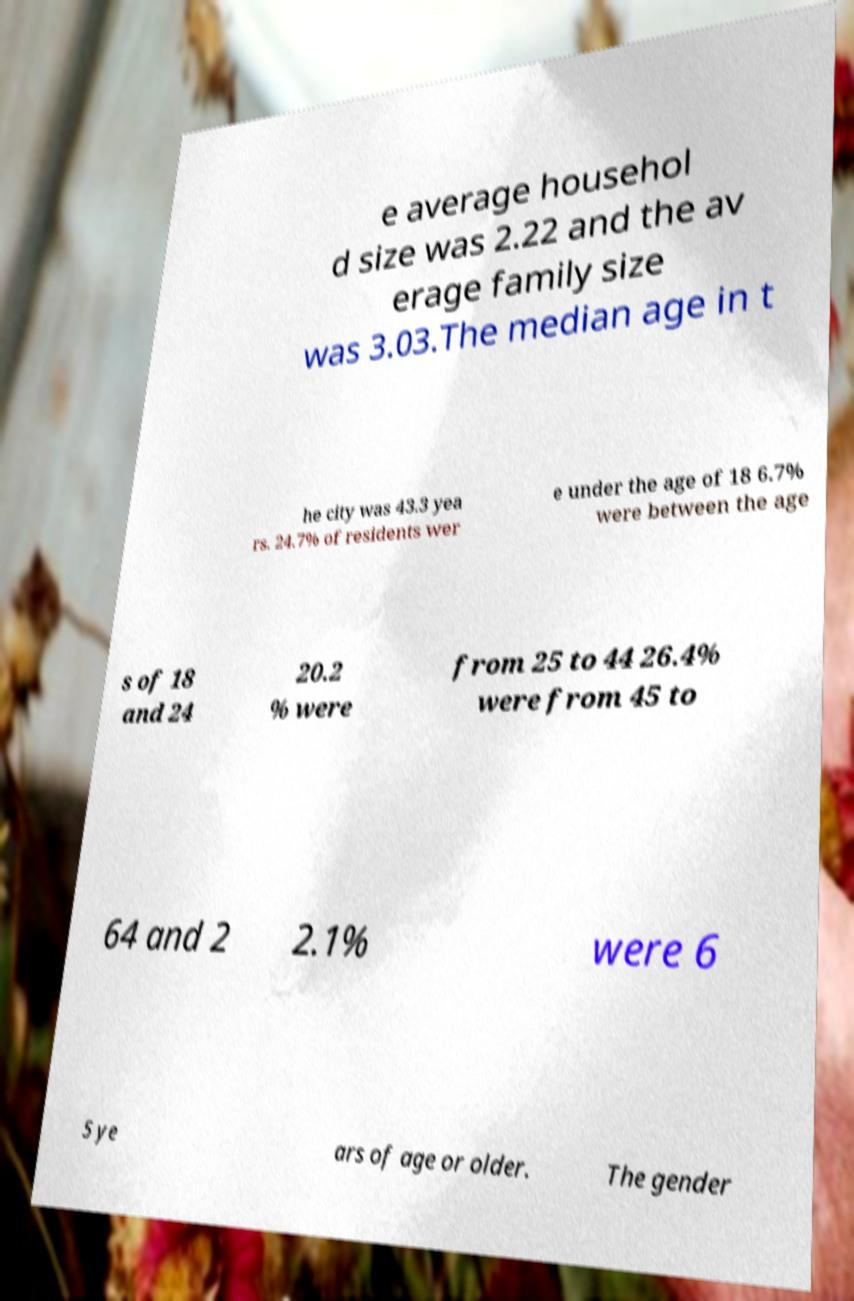There's text embedded in this image that I need extracted. Can you transcribe it verbatim? e average househol d size was 2.22 and the av erage family size was 3.03.The median age in t he city was 43.3 yea rs. 24.7% of residents wer e under the age of 18 6.7% were between the age s of 18 and 24 20.2 % were from 25 to 44 26.4% were from 45 to 64 and 2 2.1% were 6 5 ye ars of age or older. The gender 